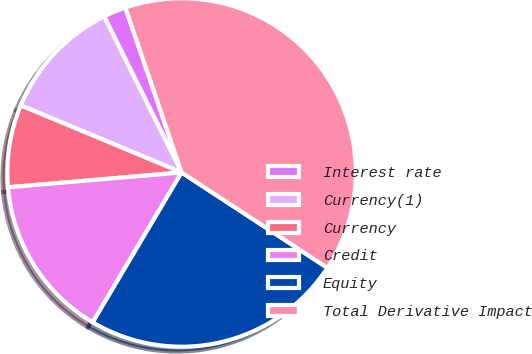Convert chart. <chart><loc_0><loc_0><loc_500><loc_500><pie_chart><fcel>Interest rate<fcel>Currency(1)<fcel>Currency<fcel>Credit<fcel>Equity<fcel>Total Derivative Impact<nl><fcel>2.1%<fcel>11.38%<fcel>7.65%<fcel>15.12%<fcel>24.3%<fcel>39.45%<nl></chart> 